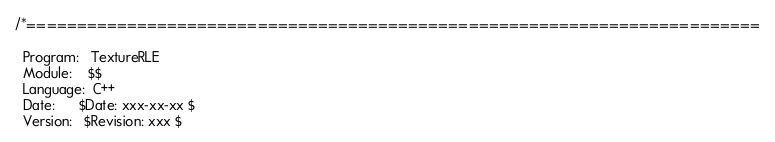Convert code to text. <code><loc_0><loc_0><loc_500><loc_500><_C_>/*=========================================================================

  Program:   TextureRLE
  Module:    $$
  Language:  C++
  Date:      $Date: xxx-xx-xx $
  Version:   $Revision: xxx $
</code> 